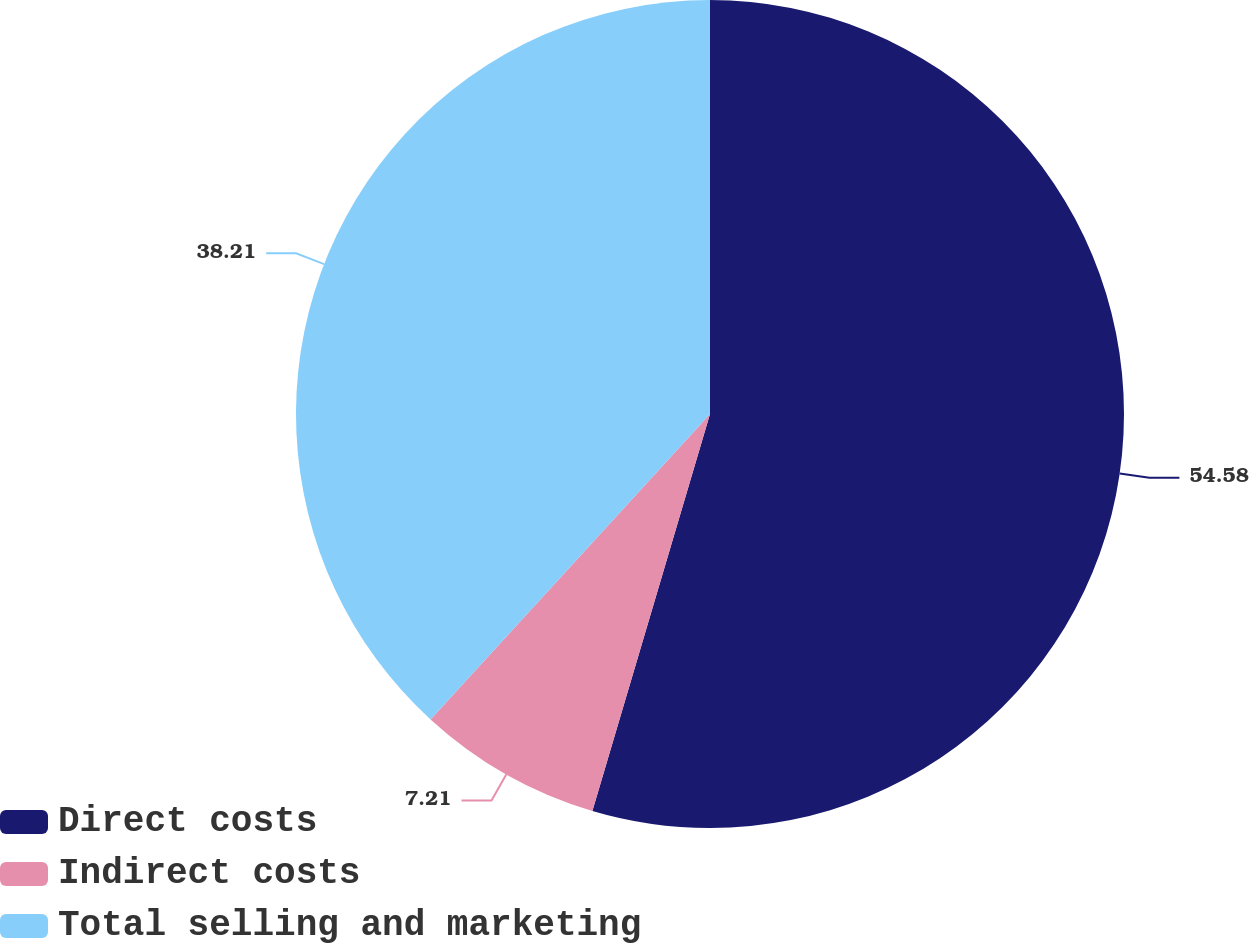Convert chart. <chart><loc_0><loc_0><loc_500><loc_500><pie_chart><fcel>Direct costs<fcel>Indirect costs<fcel>Total selling and marketing<nl><fcel>54.59%<fcel>7.21%<fcel>38.21%<nl></chart> 